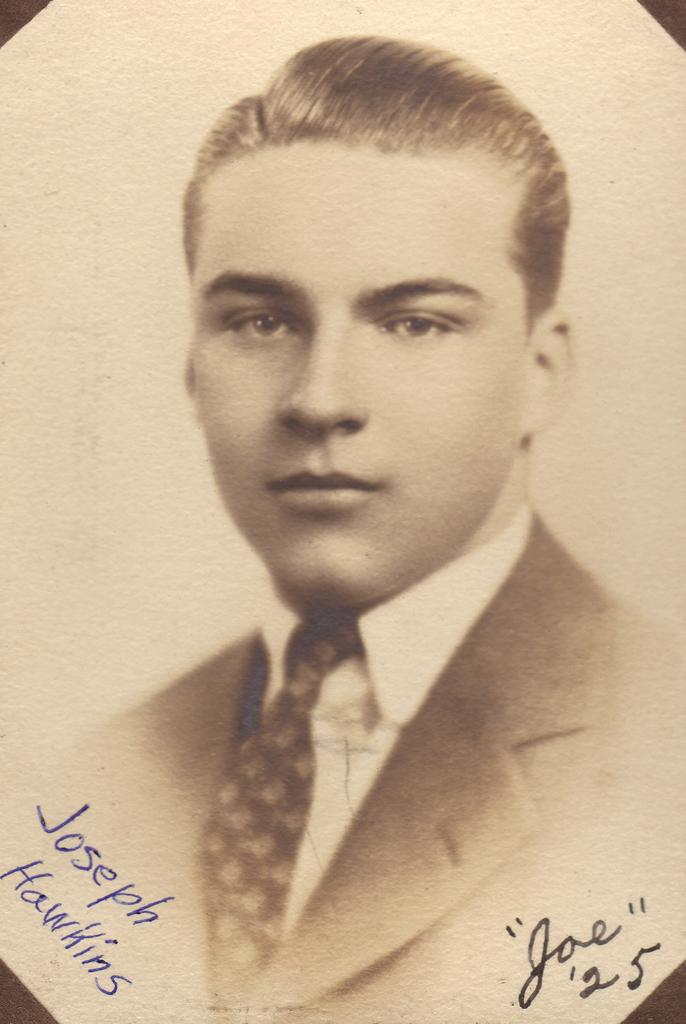What is the main subject of the picture? The main subject of the picture is a man. What type of clothing is the man wearing? The man is wearing a jacket, a shirt, and a tie. Is there any text present in the image? Yes, there is text written on the image. How many squares can be seen falling from the sky in the image? There are no squares falling from the sky in the image. What is the result of adding the numbers 2 and 3 in the image? There are no numbers or addition calculations present in the image. 